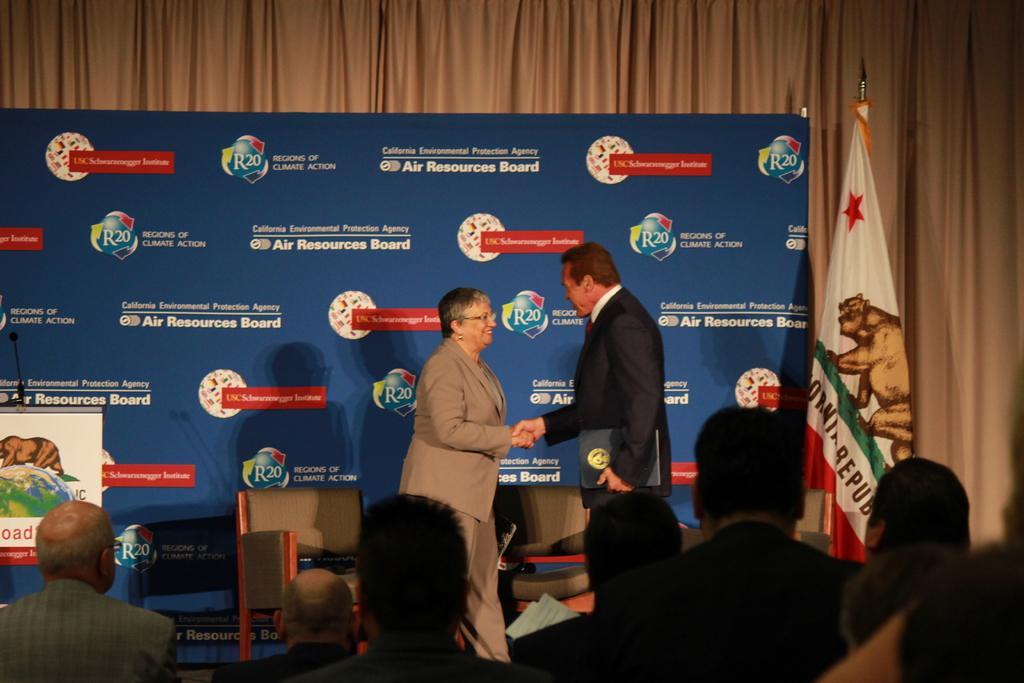How would you summarize this image in a sentence or two? In this image there are people sitting in the foreground. There is a stage. There are two people standing. We can see chairs. There is a wooden wall. We can see blue color banner with text. There is a flag. 